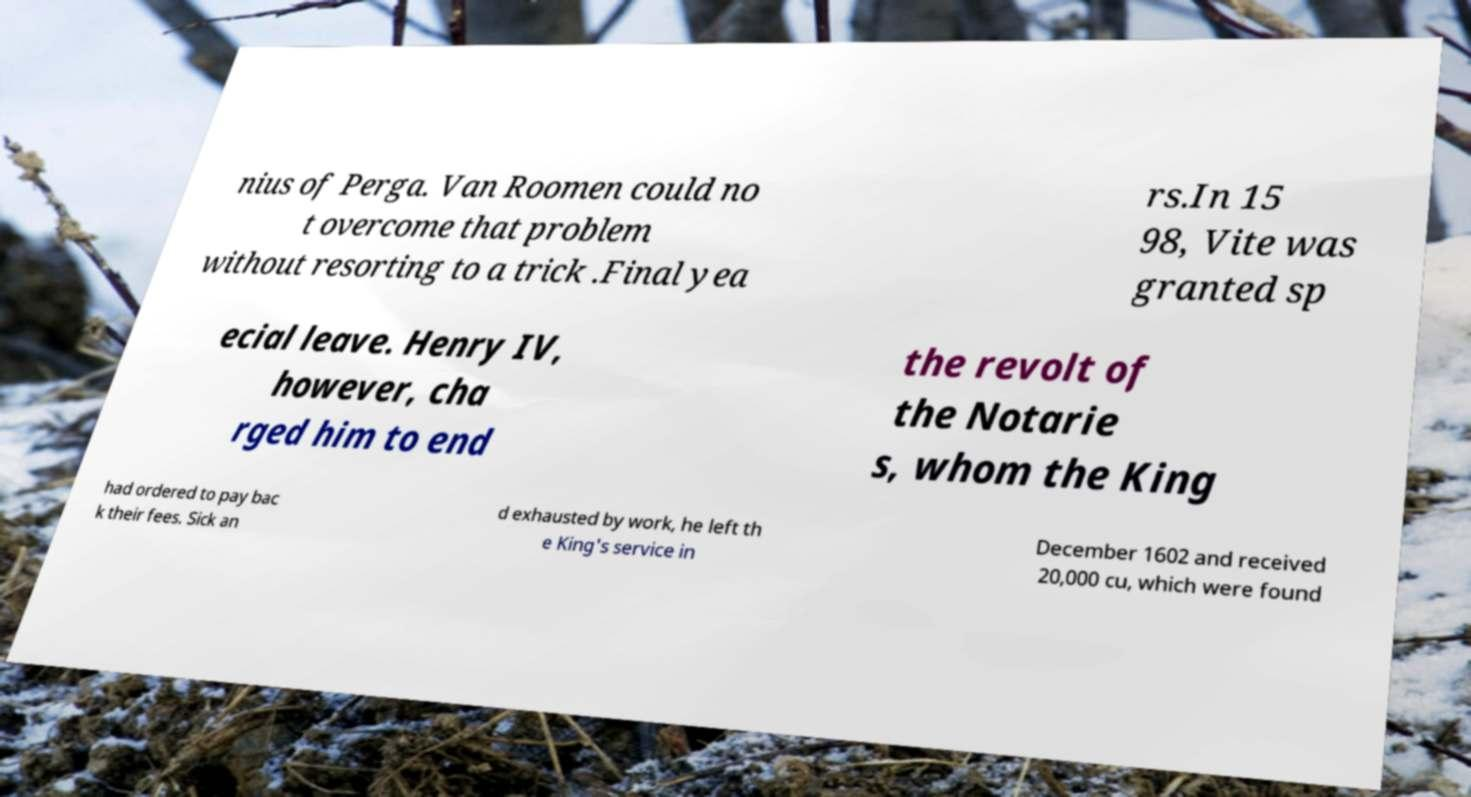For documentation purposes, I need the text within this image transcribed. Could you provide that? nius of Perga. Van Roomen could no t overcome that problem without resorting to a trick .Final yea rs.In 15 98, Vite was granted sp ecial leave. Henry IV, however, cha rged him to end the revolt of the Notarie s, whom the King had ordered to pay bac k their fees. Sick an d exhausted by work, he left th e King's service in December 1602 and received 20,000 cu, which were found 